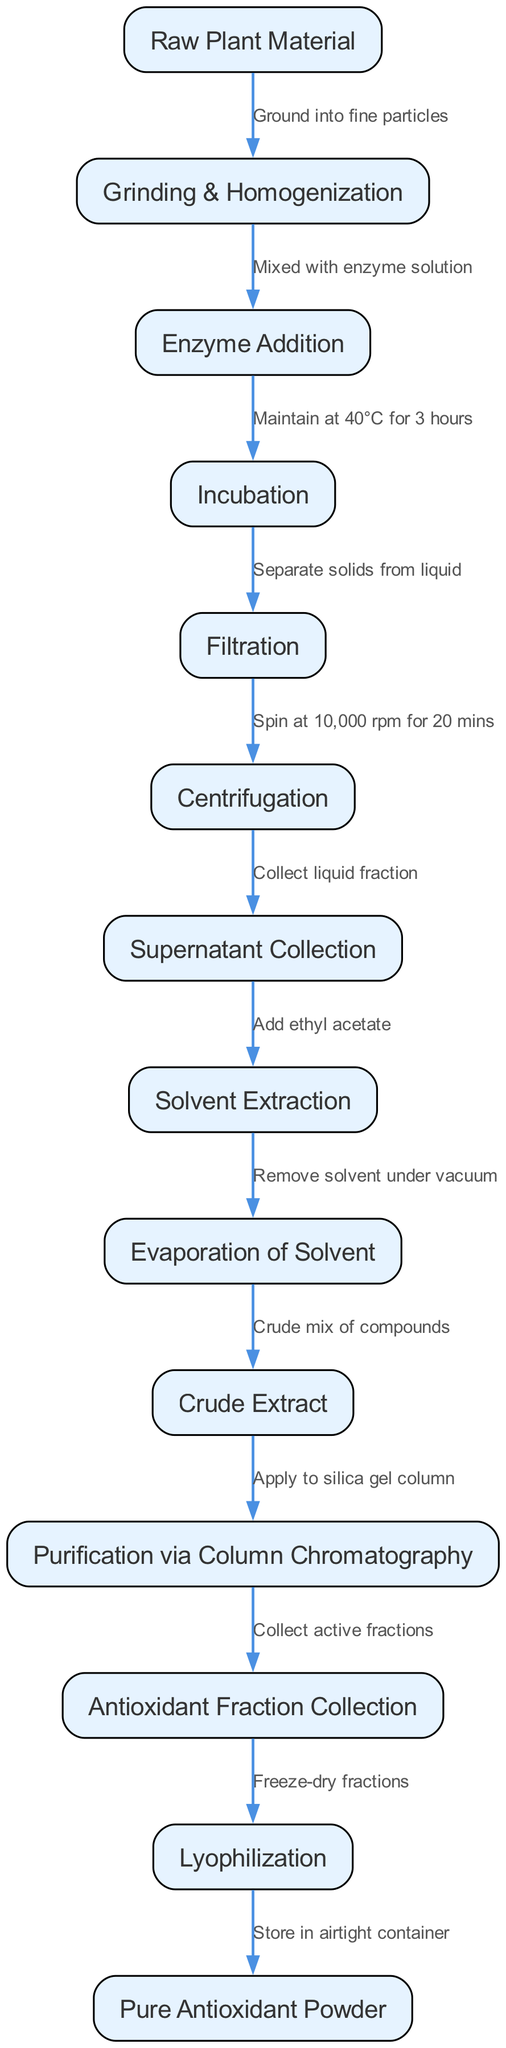What is the first step in the process? The first step is indicated by the first node in the diagram, which is labeled "Raw Plant Material." This step initiates the entire extraction and purification process.
Answer: Raw Plant Material How many nodes are present in the diagram? To determine the number of nodes, we simply count them. The diagram includes 14 nodes, each representing different steps in the process.
Answer: 14 What is added to the ground plant material? The diagram shows that after grinding and homogenization, the “Enzyme Addition” step involves mixing the ground plant material with an enzyme solution.
Answer: Enzyme solution What is collected after centrifugation? The diagram indicates that following the centrifugation step, the "Supernatant Collection" step occurs, where the liquid fraction is collected.
Answer: Liquid fraction What is the temperature maintained during incubation? From the diagram, it is specified that during the incubation step, the temperature is maintained at 40 degrees Celsius for three hours.
Answer: 40°C What is the final product obtained after lyophilization? The last step in the flowchart, following lyophilization, leads to the output labeled "Pure Antioxidant Powder," which signifies the final product of the purification process.
Answer: Pure Antioxidant Powder What process is used for the purification of the crude extract? According to the diagram, the purification of the crude extract is done via “Column Chromatography,” which is specifically indicated as the process prior to collecting the antioxidant fractions.
Answer: Column Chromatography How many edges are there in the diagram? The number of edges can be counted by examining the connections between the nodes. In this case, there are 13 edges illustrating the flow of the process.
Answer: 13 What solvent is used for extraction? The diagram states that during the "Solvent Extraction" step, ethyl acetate is added, which is the solvent utilized in the extraction process.
Answer: Ethyl acetate 